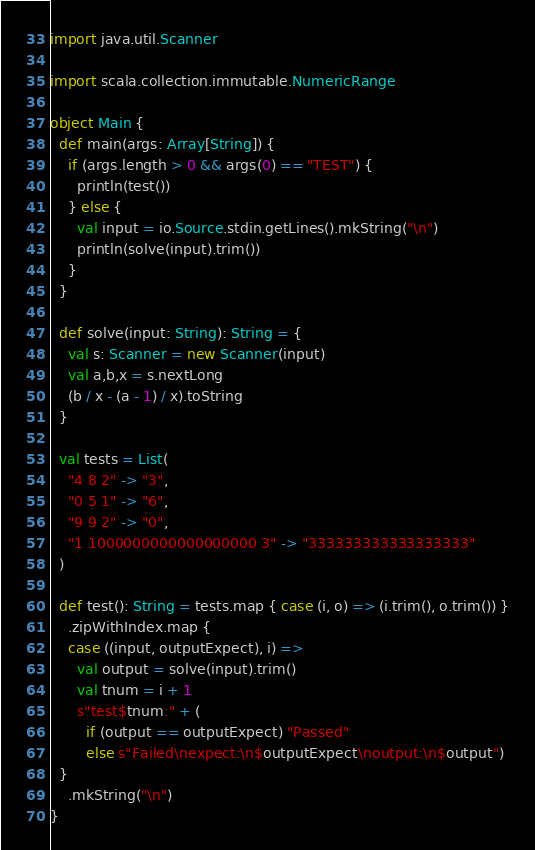Convert code to text. <code><loc_0><loc_0><loc_500><loc_500><_Scala_>import java.util.Scanner

import scala.collection.immutable.NumericRange

object Main {
  def main(args: Array[String]) {
    if (args.length > 0 && args(0) == "TEST") {
      println(test())
    } else {
      val input = io.Source.stdin.getLines().mkString("\n")
      println(solve(input).trim())
    }
  }

  def solve(input: String): String = {
    val s: Scanner = new Scanner(input)
    val a,b,x = s.nextLong
    (b / x - (a - 1) / x).toString
  }

  val tests = List(
    "4 8 2" -> "3",
    "0 5 1" -> "6",
    "9 9 2" -> "0",
    "1 1000000000000000000 3" -> "333333333333333333"
  )

  def test(): String = tests.map { case (i, o) => (i.trim(), o.trim()) }
    .zipWithIndex.map {
    case ((input, outputExpect), i) =>
      val output = solve(input).trim()
      val tnum = i + 1
      s"test$tnum:" + (
        if (output == outputExpect) "Passed"
        else s"Failed\nexpect:\n$outputExpect\noutput:\n$output")
  }
    .mkString("\n")
}</code> 